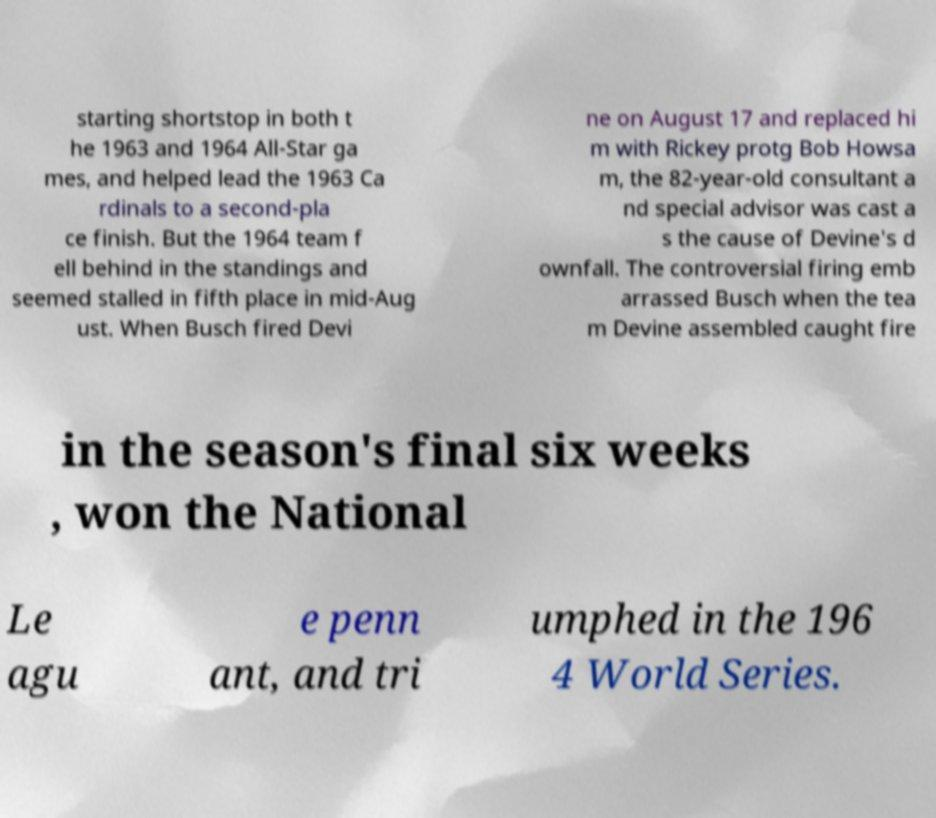There's text embedded in this image that I need extracted. Can you transcribe it verbatim? starting shortstop in both t he 1963 and 1964 All-Star ga mes, and helped lead the 1963 Ca rdinals to a second-pla ce finish. But the 1964 team f ell behind in the standings and seemed stalled in fifth place in mid-Aug ust. When Busch fired Devi ne on August 17 and replaced hi m with Rickey protg Bob Howsa m, the 82-year-old consultant a nd special advisor was cast a s the cause of Devine's d ownfall. The controversial firing emb arrassed Busch when the tea m Devine assembled caught fire in the season's final six weeks , won the National Le agu e penn ant, and tri umphed in the 196 4 World Series. 